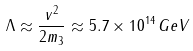Convert formula to latex. <formula><loc_0><loc_0><loc_500><loc_500>\Lambda \approx \frac { v ^ { 2 } } { 2 m _ { 3 } } \approx 5 . 7 \times 1 0 ^ { 1 4 } \, G e V</formula> 